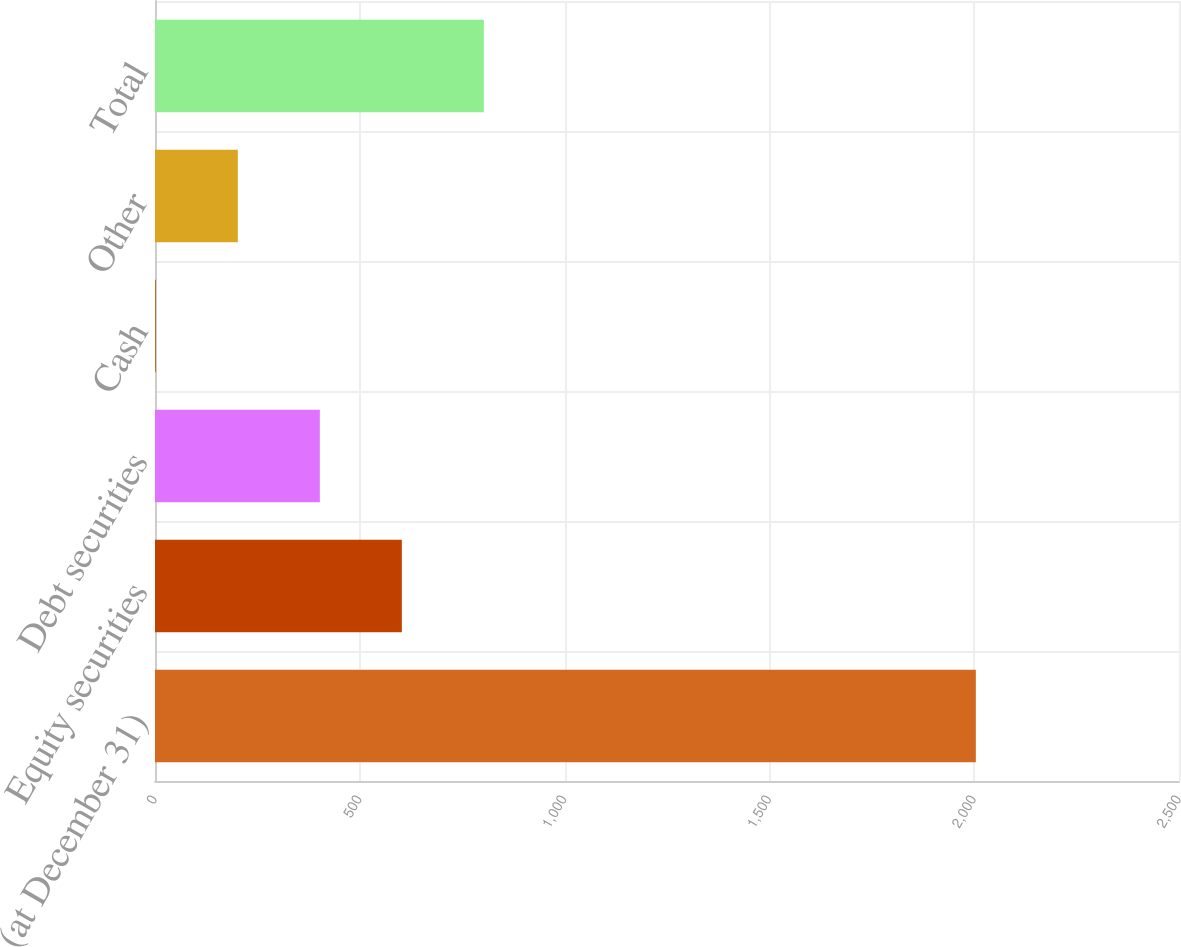Convert chart to OTSL. <chart><loc_0><loc_0><loc_500><loc_500><bar_chart><fcel>(at December 31)<fcel>Equity securities<fcel>Debt securities<fcel>Cash<fcel>Other<fcel>Total<nl><fcel>2004<fcel>602.6<fcel>402.4<fcel>2<fcel>202.2<fcel>802.8<nl></chart> 